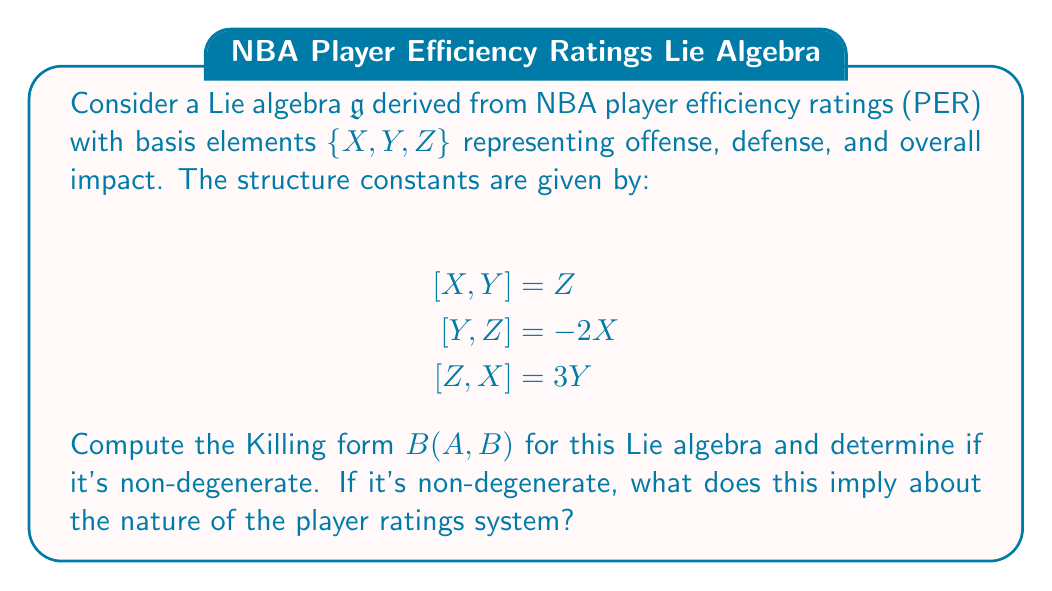Show me your answer to this math problem. Let's approach this step-by-step:

1) The Killing form is defined as $B(A,B) = \text{tr}(\text{ad}_A \circ \text{ad}_B)$, where $\text{ad}_A$ is the adjoint representation of $A$.

2) First, we need to find the matrix representations of $\text{ad}_X$, $\text{ad}_Y$, and $\text{ad}_Z$:

   $\text{ad}_X = \begin{pmatrix} 0 & 0 & 3 \\ 0 & 0 & 0 \\ 0 & 1 & 0 \end{pmatrix}$

   $\text{ad}_Y = \begin{pmatrix} 0 & 0 & 0 \\ 0 & 0 & -2 \\ 1 & 0 & 0 \end{pmatrix}$

   $\text{ad}_Z = \begin{pmatrix} 0 & -3 & 0 \\ 2 & 0 & 0 \\ 0 & 0 & 0 \end{pmatrix}$

3) Now, we compute $B(X,X)$, $B(Y,Y)$, $B(Z,Z)$, $B(X,Y)$, $B(Y,Z)$, and $B(X,Z)$:

   $B(X,X) = \text{tr}(\text{ad}_X \circ \text{ad}_X) = 0$
   $B(Y,Y) = \text{tr}(\text{ad}_Y \circ \text{ad}_Y) = 0$
   $B(Z,Z) = \text{tr}(\text{ad}_Z \circ \text{ad}_Z) = 0$
   $B(X,Y) = \text{tr}(\text{ad}_X \circ \text{ad}_Y) = -3$
   $B(Y,Z) = \text{tr}(\text{ad}_Y \circ \text{ad}_Z) = -6$
   $B(X,Z) = \text{tr}(\text{ad}_X \circ \text{ad}_Z) = 9$

4) The Killing form matrix is therefore:

   $B = \begin{pmatrix} 0 & -3 & 9 \\ -3 & 0 & -6 \\ 9 & -6 & 0 \end{pmatrix}$

5) To determine if it's non-degenerate, we calculate the determinant:

   $\det(B) = 0(0) - (-3)(-6) - 9(9) = -99$

6) Since $\det(B) \neq 0$, the Killing form is non-degenerate.

7) A non-degenerate Killing form implies that the Lie algebra is semisimple. In the context of player ratings, this suggests that the rating system captures independent aspects of player performance (offense, defense, overall impact) without redundancy, and each aspect contributes significantly to the overall rating.
Answer: The Killing form for the given Lie algebra is:

$$B = \begin{pmatrix} 0 & -3 & 9 \\ -3 & 0 & -6 \\ 9 & -6 & 0 \end{pmatrix}$$

It is non-degenerate (det(B) = -99 ≠ 0), implying that the Lie algebra is semisimple. This suggests that the player ratings system captures independent, significant aspects of performance without redundancy. 